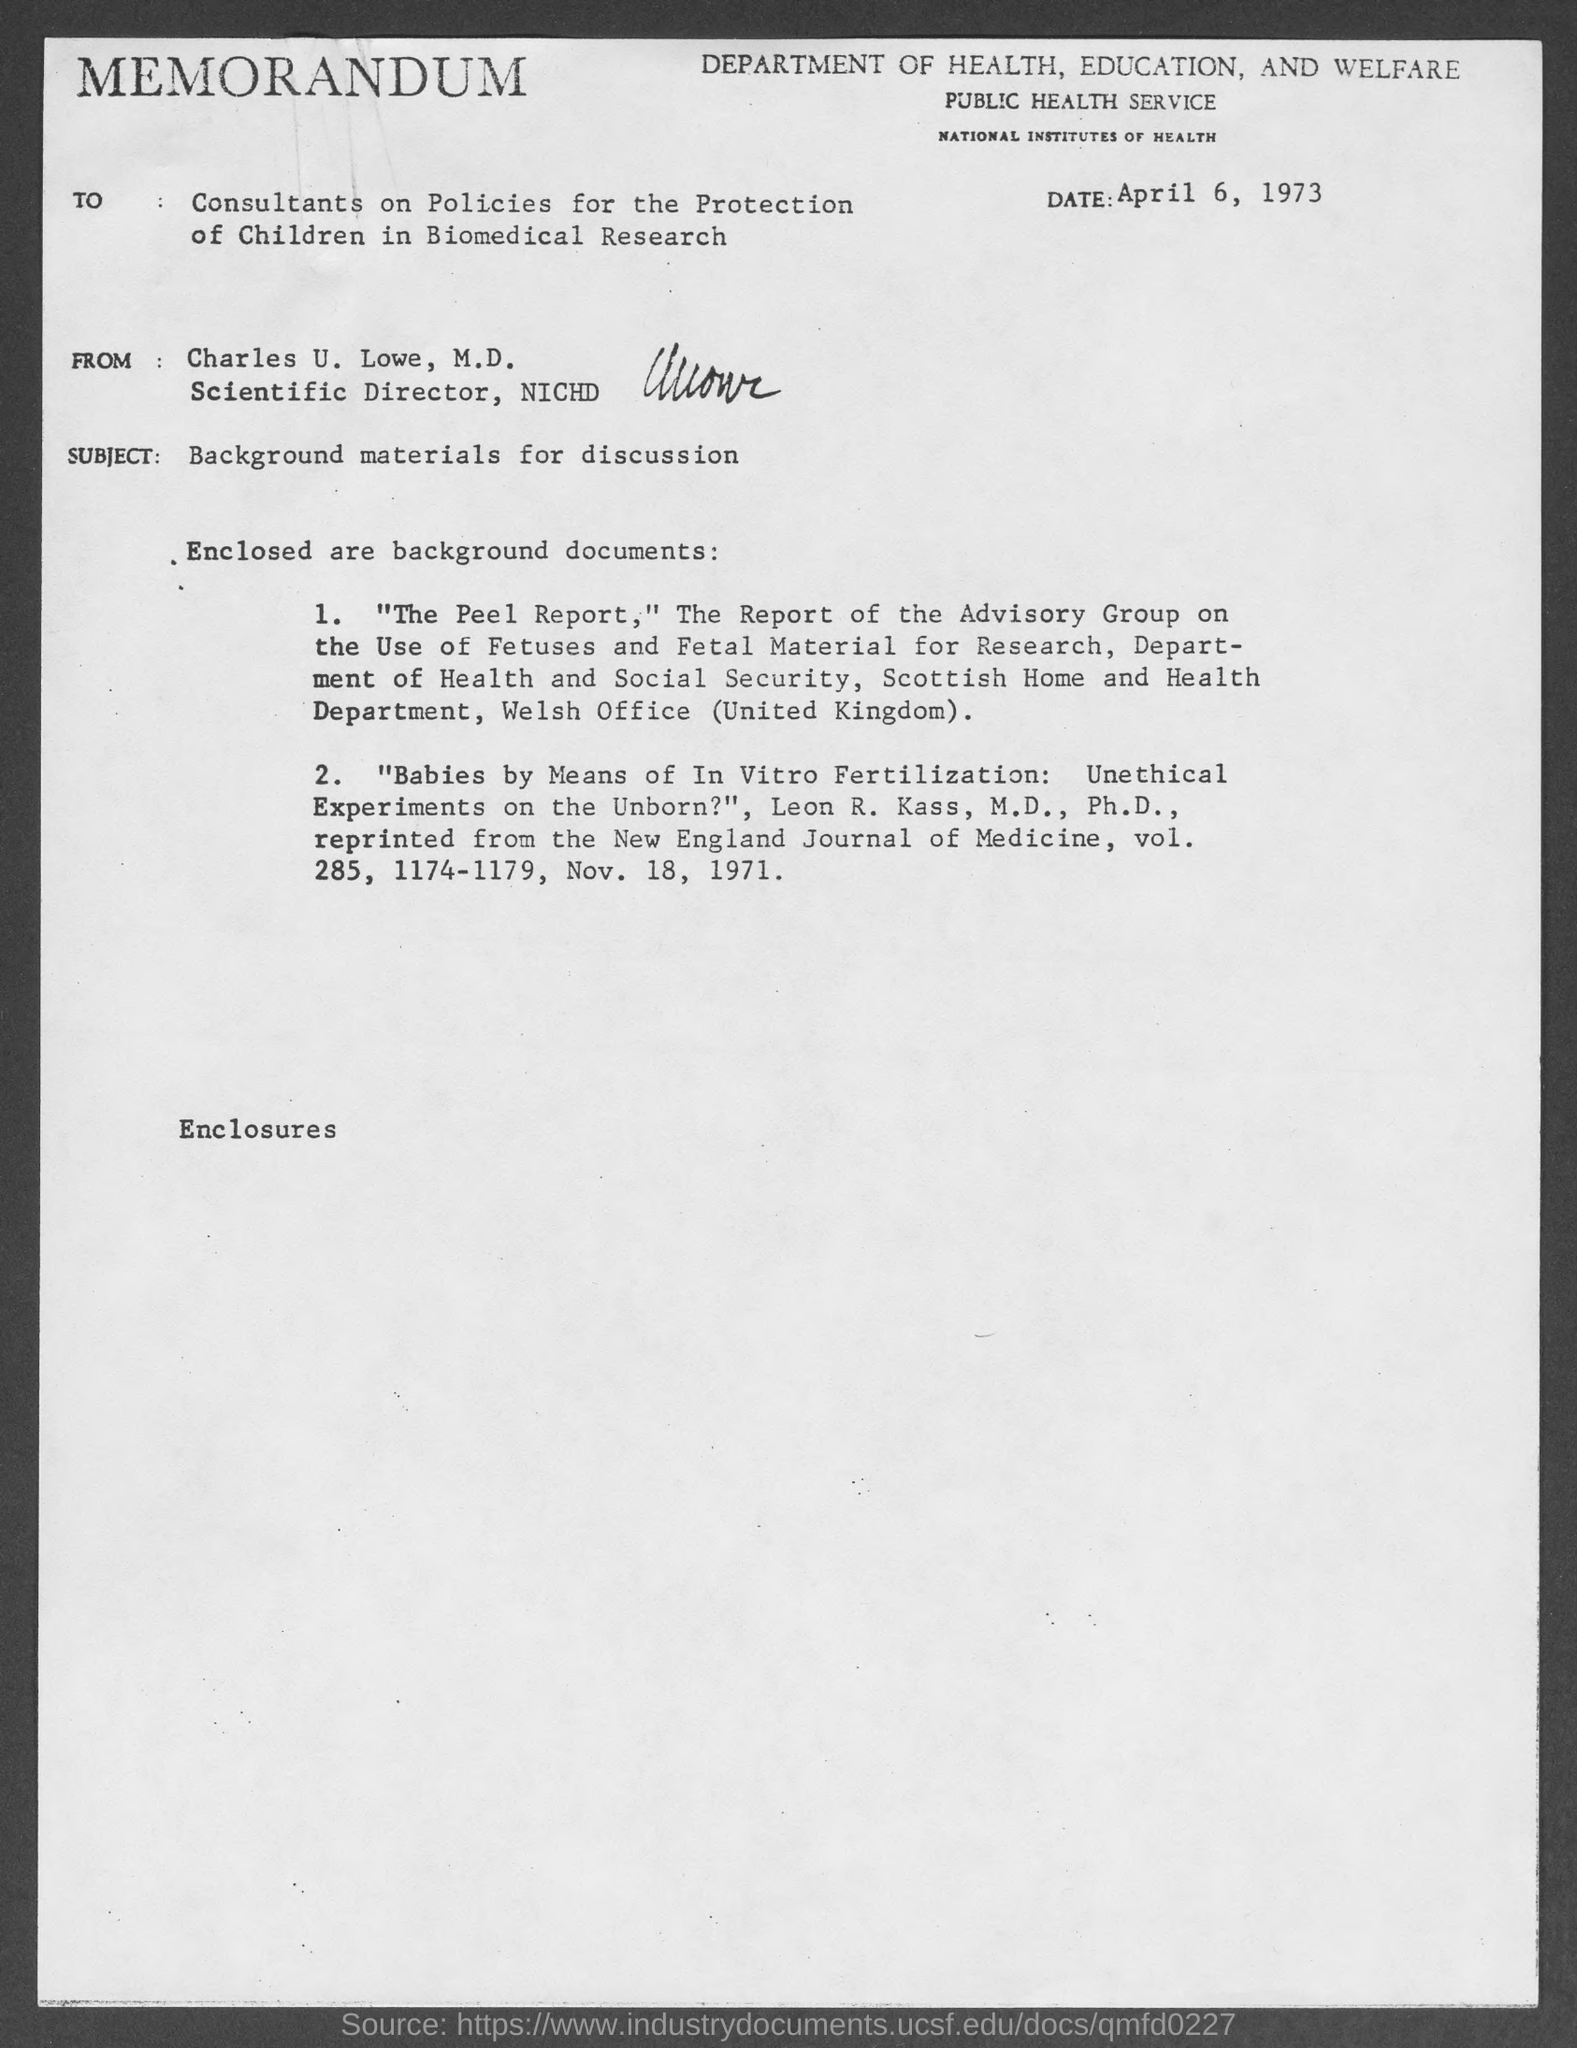What is the date mentioned in the memorandum?
Your answer should be very brief. April 6, 1973. Who is the sender of this memorandum?
Ensure brevity in your answer.  Charles U. Lowe, M.D. What is the subject of this memorandum?
Make the answer very short. Background materials for discussion. 